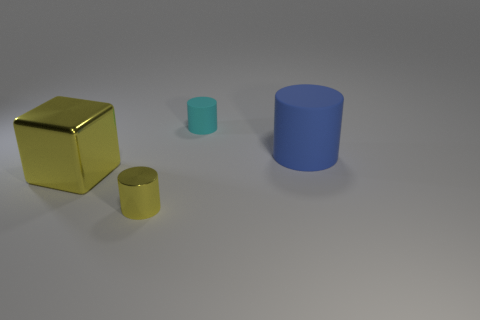How many blue objects are either large metallic things or small cylinders?
Provide a short and direct response. 0. How many cubes are the same color as the tiny matte cylinder?
Make the answer very short. 0. Are there any other things that have the same shape as the small metallic thing?
Your answer should be very brief. Yes. What number of cylinders are yellow metallic things or tiny cyan matte objects?
Your answer should be very brief. 2. There is a cylinder that is to the right of the small matte object; what color is it?
Your answer should be very brief. Blue. What is the shape of the matte thing that is the same size as the yellow cube?
Your answer should be very brief. Cylinder. There is a small rubber cylinder; how many big objects are to the right of it?
Offer a very short reply. 1. How many things are big blue rubber objects or gray cubes?
Make the answer very short. 1. There is a object that is both behind the yellow metallic cylinder and in front of the big blue rubber cylinder; what is its shape?
Your response must be concise. Cube. What number of tiny cyan rubber blocks are there?
Offer a terse response. 0. 